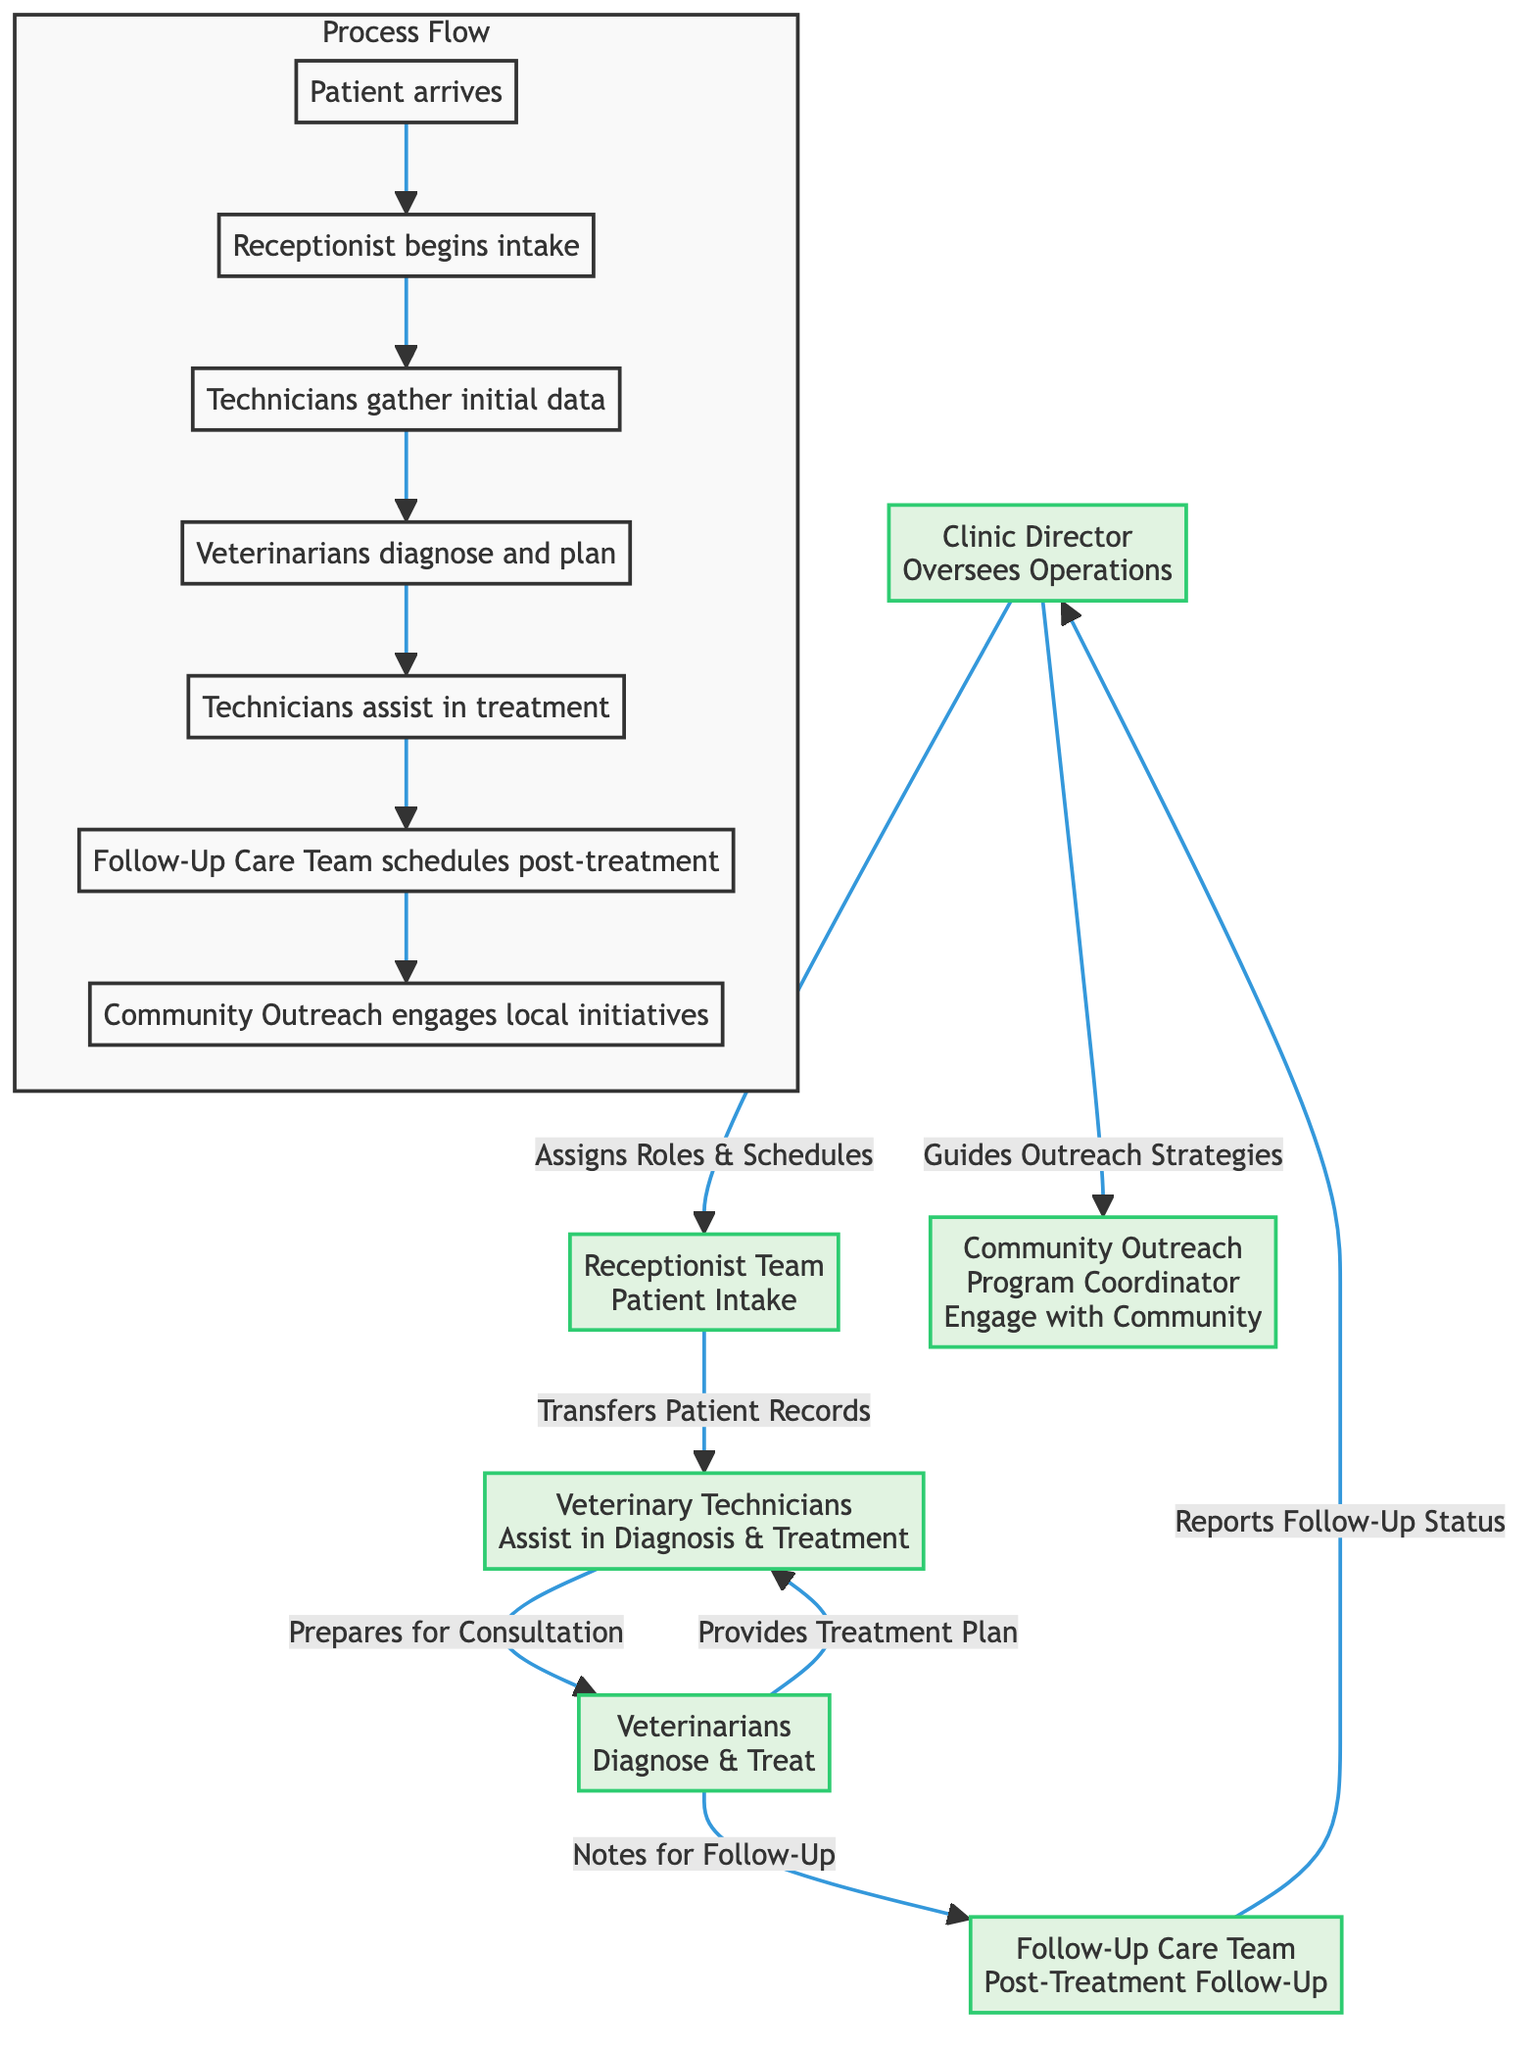What is the role of the "Follow-Up Care Team"? The "Follow-Up Care Team" is responsible for post-treatment follow-up. This is indicated in the organizational chart where it clearly states the role of that team.
Answer: Post-Treatment Follow-Up How many teams are directly involved in patient care? In the diagram, there are four main teams involved in patient care: Receptionist Team, Veterinary Technicians, Veterinarians, and Follow-Up Care Team. Upon reviewing the diagram, these teams were identified as directly participating in the patient care process.
Answer: Four Who guides outreach strategies? The "Clinic Director" is the one who guides outreach strategies in the diagram. This is depicted by the directed line from the Clinic Director to the Community Outreach section.
Answer: Clinic Director What follows after the Technicians gather initial data? After the Technicians gather initial data, the next step in the flow is that the Veterinarians diagnose and plan. Following the flow from the Technicians, the next node leads to the Veterinarians.
Answer: Veterinarians diagnose and plan How does the workflow begin according to the diagram? The workflow begins with the patient arriving, as shown in the first step of the Process Flow in the diagram. This step initiates the entire process outlined in the organizational structure.
Answer: Patient arrives Which team transfers patient records? The "Receptionist Team" is responsible for transferring patient records to the Veterinary Technicians. This is indicated in the diagram showing the connection between these two roles.
Answer: Receptionist Team What does the Community Outreach program focus on? The Community Outreach program focuses on engaging with the community, as explicitly stated in the diagram relating to the responsibilities of the Community Outreach role.
Answer: Engage with Community What is the final step involving community initiatives? The final step involving community initiatives is when the Community Outreach engages local initiatives. This is shown as the last part of the Process Flow linked with the Follow-Up Care Team.
Answer: Community Outreach engages local initiatives 